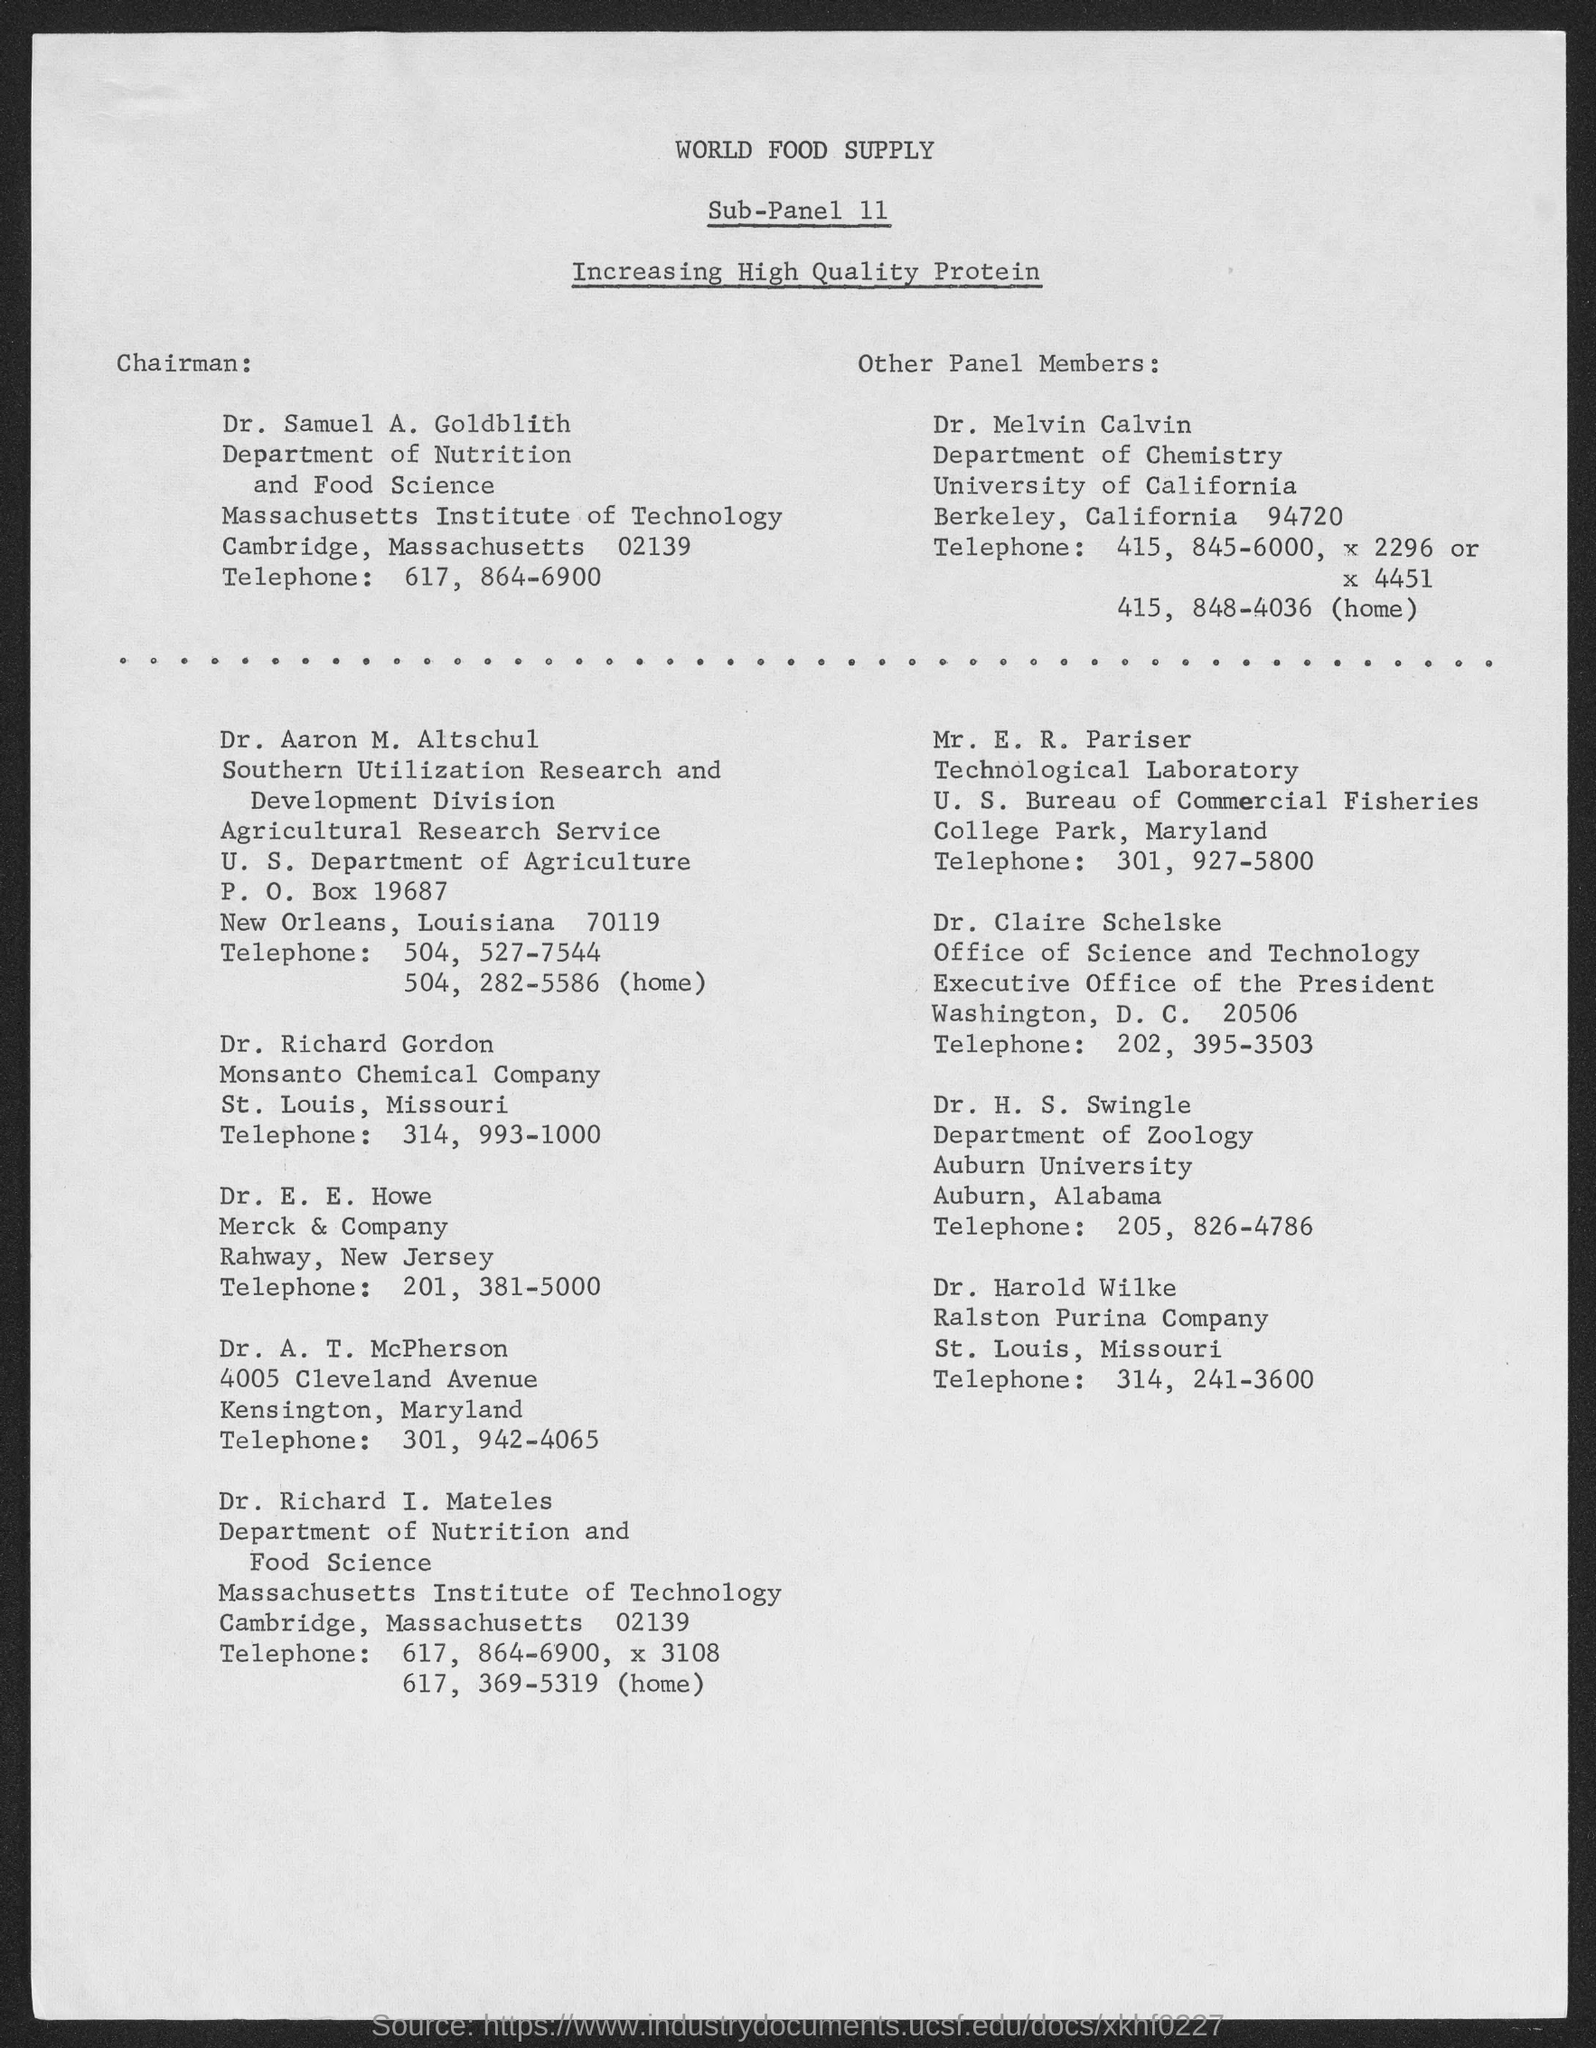Who is the Chairman of Sub-Panel 11?
Provide a short and direct response. Dr. Samuel A. Goldblith. What is the Telephone No. of Dr. Samuel A. Goldblith mentioned in this document?
Keep it short and to the point. 617, 864-6900. 